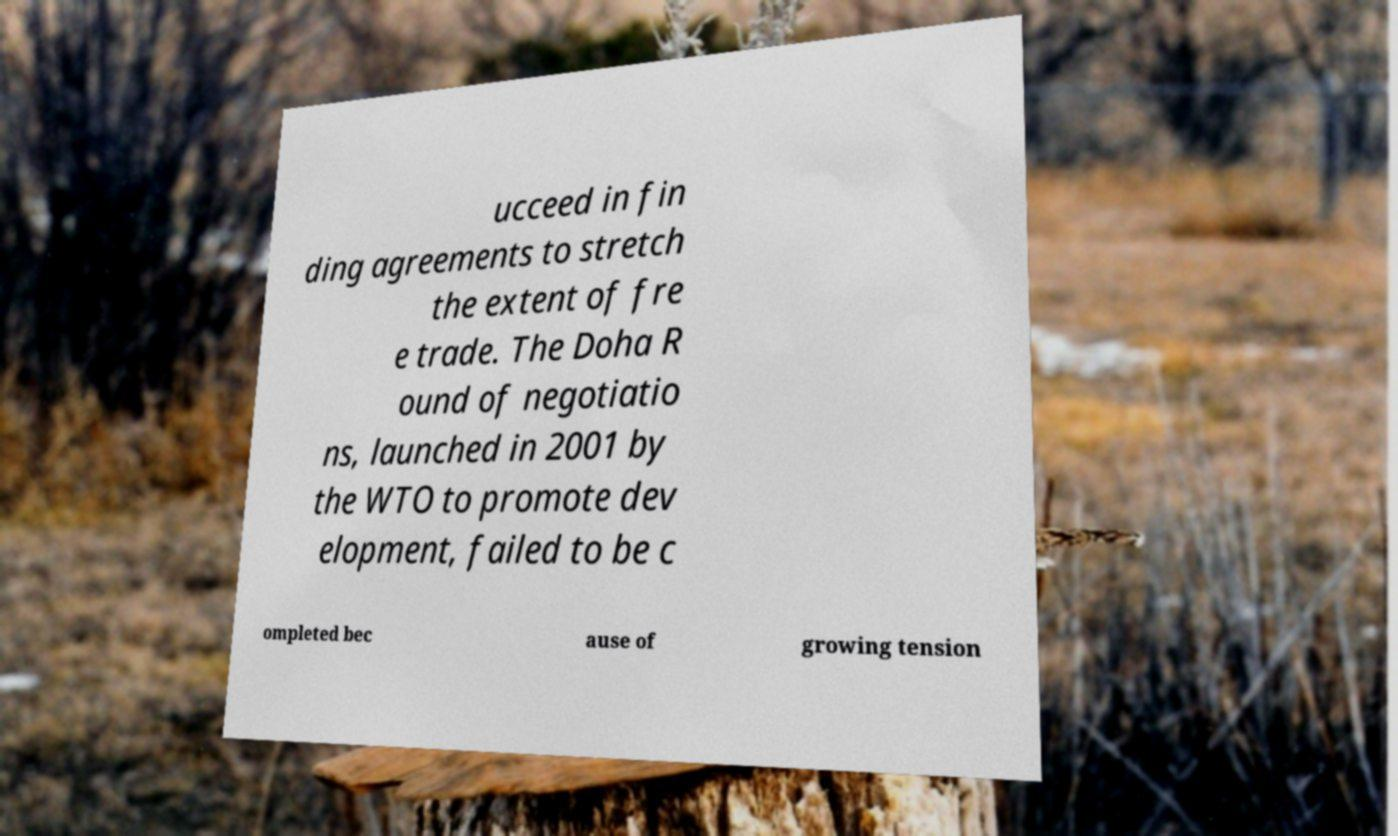There's text embedded in this image that I need extracted. Can you transcribe it verbatim? ucceed in fin ding agreements to stretch the extent of fre e trade. The Doha R ound of negotiatio ns, launched in 2001 by the WTO to promote dev elopment, failed to be c ompleted bec ause of growing tension 